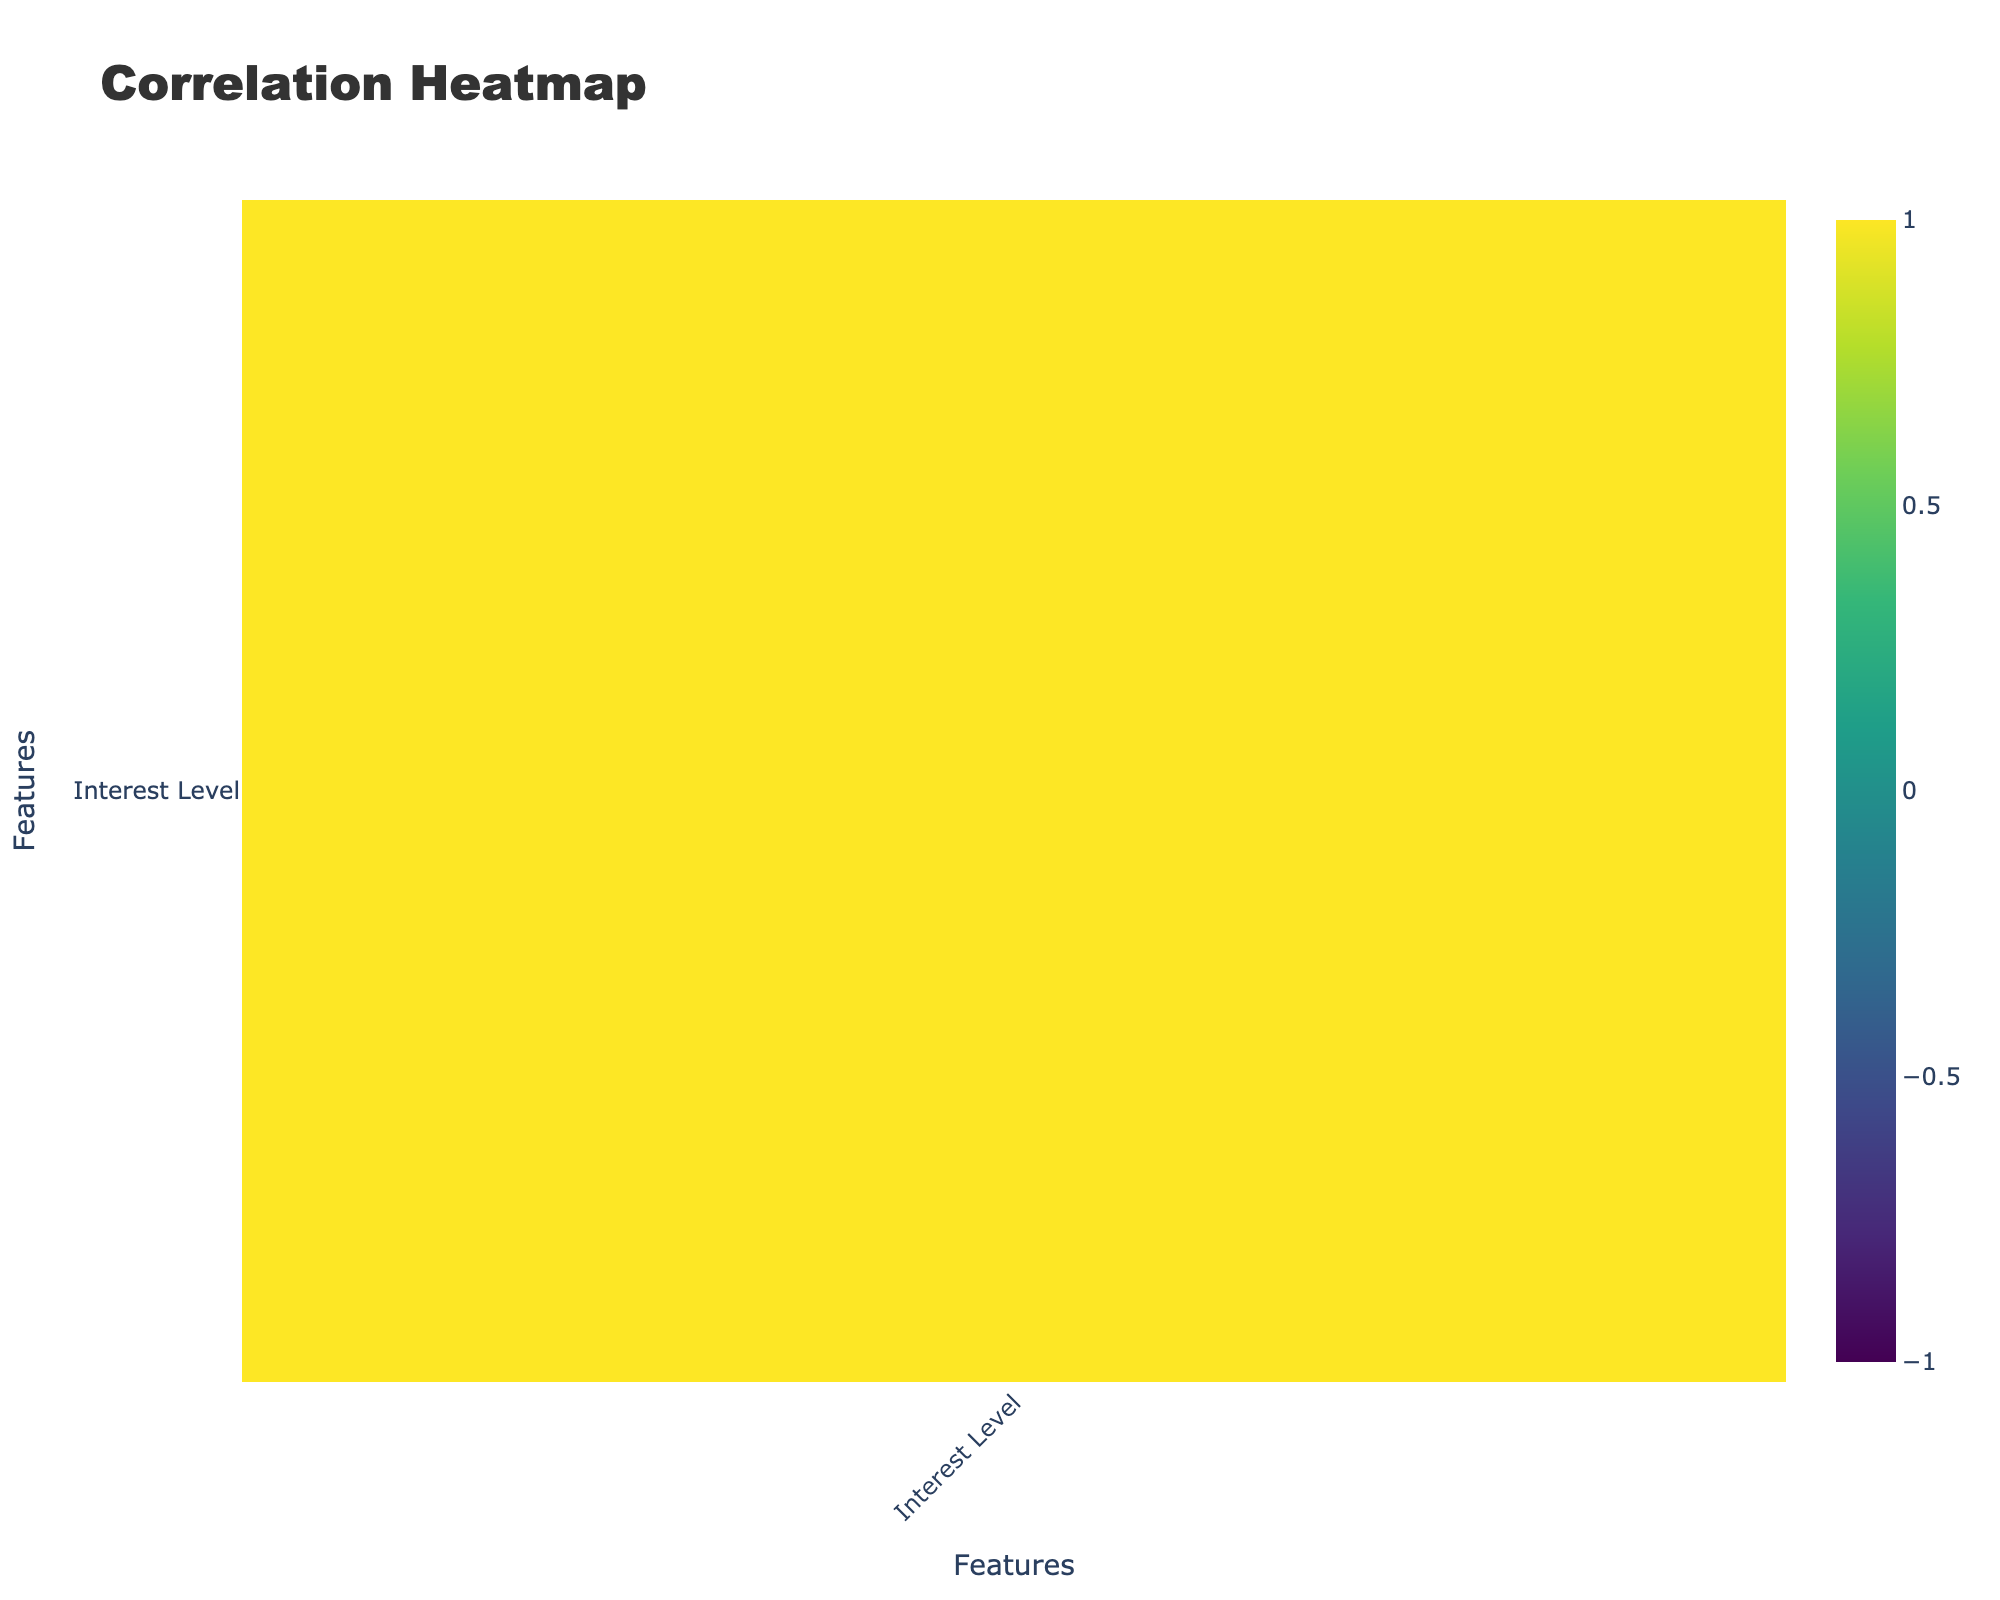What is the interest level of Female attendees for the Documentary genre? Looking at the table, there is one entry for Female attendees with the Film Genre as Documentary which has an Interest Level of 7.
Answer: 7 What is the interest level for Male attendees showcasing Action films? In the table, there is one entry for Male attendees showcasing Action films, which has an Interest Level of 6.
Answer: 6 What film genre has the highest average interest level among all attendees? To find this, we calculate the average interest level for each genre: Indie (8), Documentary (7), Action (6), Romantic Comedy (8), Sci-Fi (5), Thriller (8), Shorts (7), Horror (9), Animation (6), Drama (7), Fantasy (4), Historical (8). The highest average is for Horror which is 9.
Answer: Horror Is there any film genre that was not showcased by any attendees in the table? All entries have at least one genre showcased since every row represents a film genre that was featured at an event. Therefore, there are no genres absent from the table.
Answer: No What is the difference in interest level between the highest-rated genre and the lowest-rated genre? The highest interest level is 9 for the Horror genre, and the lowest is 4 for the Fantasy genre. Thus, the difference is 9 - 4 = 5.
Answer: 5 Do Male attendees from Los Angeles prefer shorts over horror films? The Interest Level for Shorts (Male, Los Angeles) is 7, while for Horror (Female, Austin) it is 9. So, they do not prefer shorts over horror films.
Answer: No What is the average interest level of attendees aged 35-44 for the genres showcased? We find the Interest Levels for this age group: Sci-Fi (5), Thriller (8), Fantasy (4), Historical (8). The sum is (5 + 8 + 4 + 8) = 25 and there are 4 data points, so the average is 25/4 = 6.25.
Answer: 6.25 Are there any females interested in Action films? The table shows one entry for females in the Action genre with an interest level of 6. Therefore, there are female attendees interested in Action films.
Answer: Yes What percentage of attendees under 35 are interested in Romantic Comedy? There are two entries for attendees under 35 interested in Romantic Comedy: one Male (25-34, 6) and one Female (25-34, 9). Total interest level is 6 + 9 = 15. There are 6 total entries under 35. Calculating the percentage, (15/6) * 100 = 250%.
Answer: 250% 